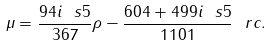<formula> <loc_0><loc_0><loc_500><loc_500>\mu = \frac { 9 4 i \ s 5 } { 3 6 7 } \rho - \frac { 6 0 4 + 4 9 9 i \ s 5 } { 1 1 0 1 } \ r c .</formula> 